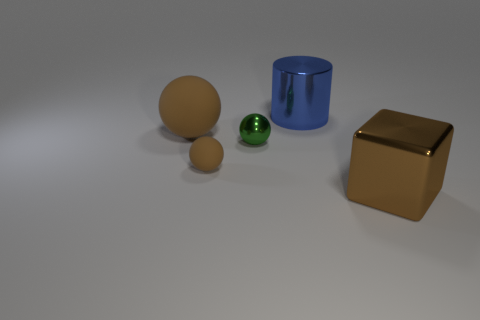Subtract all matte balls. How many balls are left? 1 Add 3 big gray shiny cylinders. How many objects exist? 8 Subtract all brown spheres. How many spheres are left? 1 Subtract 0 purple cylinders. How many objects are left? 5 Subtract all cylinders. How many objects are left? 4 Subtract 3 balls. How many balls are left? 0 Subtract all cyan cubes. Subtract all purple balls. How many cubes are left? 1 Subtract all green cubes. How many brown balls are left? 2 Subtract all blue objects. Subtract all cylinders. How many objects are left? 3 Add 5 blue metallic cylinders. How many blue metallic cylinders are left? 6 